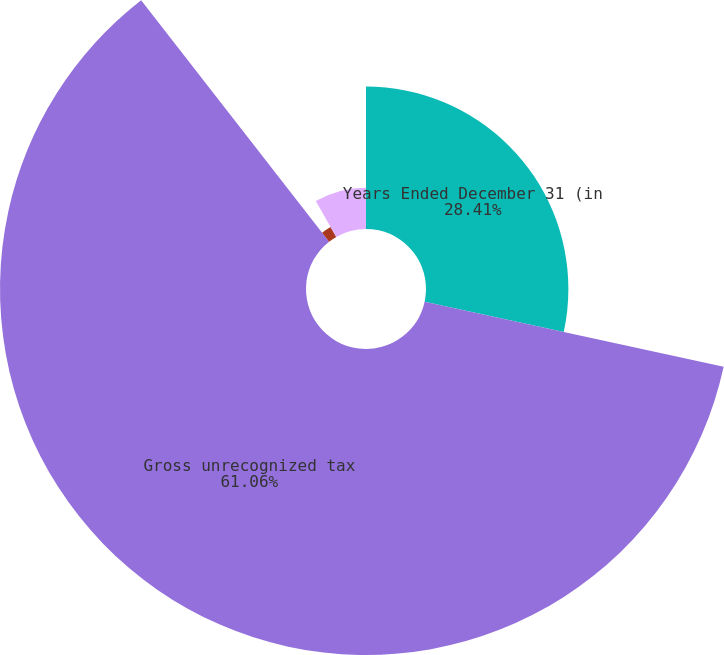Convert chart to OTSL. <chart><loc_0><loc_0><loc_500><loc_500><pie_chart><fcel>Years Ended December 31 (in<fcel>Gross unrecognized tax<fcel>Increases in tax positions for<fcel>Decreases in tax positions for<nl><fcel>28.41%<fcel>61.06%<fcel>2.28%<fcel>8.25%<nl></chart> 